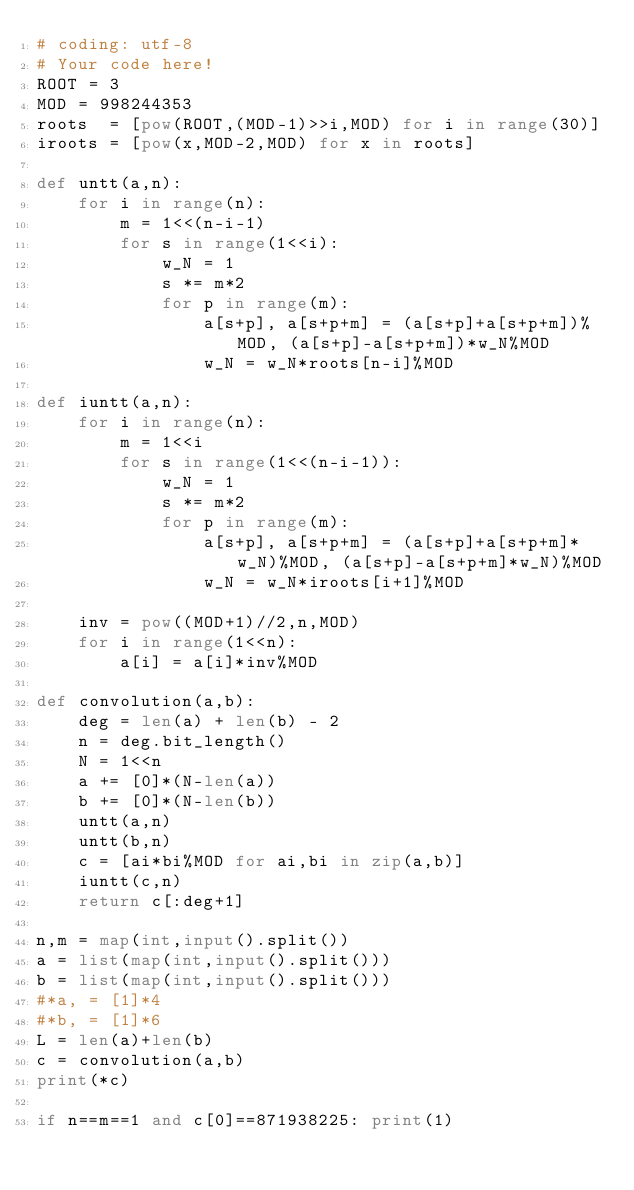<code> <loc_0><loc_0><loc_500><loc_500><_Python_># coding: utf-8
# Your code here!
ROOT = 3
MOD = 998244353
roots  = [pow(ROOT,(MOD-1)>>i,MOD) for i in range(30)]
iroots = [pow(x,MOD-2,MOD) for x in roots]

def untt(a,n):
    for i in range(n):
        m = 1<<(n-i-1)
        for s in range(1<<i):
            w_N = 1
            s *= m*2
            for p in range(m):
                a[s+p], a[s+p+m] = (a[s+p]+a[s+p+m])%MOD, (a[s+p]-a[s+p+m])*w_N%MOD
                w_N = w_N*roots[n-i]%MOD

def iuntt(a,n):
    for i in range(n):
        m = 1<<i
        for s in range(1<<(n-i-1)):
            w_N = 1
            s *= m*2
            for p in range(m):
                a[s+p], a[s+p+m] = (a[s+p]+a[s+p+m]*w_N)%MOD, (a[s+p]-a[s+p+m]*w_N)%MOD
                w_N = w_N*iroots[i+1]%MOD
            
    inv = pow((MOD+1)//2,n,MOD)
    for i in range(1<<n):
        a[i] = a[i]*inv%MOD

def convolution(a,b):
    deg = len(a) + len(b) - 2
    n = deg.bit_length()
    N = 1<<n
    a += [0]*(N-len(a))
    b += [0]*(N-len(b))
    untt(a,n)
    untt(b,n)
    c = [ai*bi%MOD for ai,bi in zip(a,b)]
    iuntt(c,n)
    return c[:deg+1]

n,m = map(int,input().split())
a = list(map(int,input().split()))
b = list(map(int,input().split()))
#*a, = [1]*4
#*b, = [1]*6
L = len(a)+len(b)
c = convolution(a,b)
print(*c)

if n==m==1 and c[0]==871938225: print(1)

</code> 